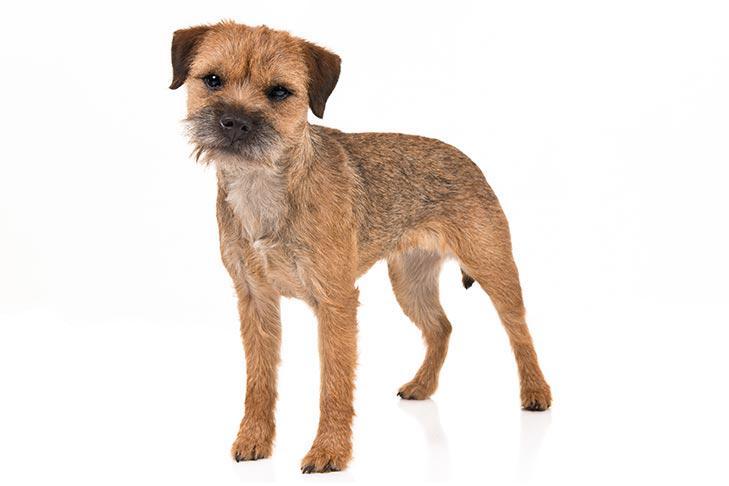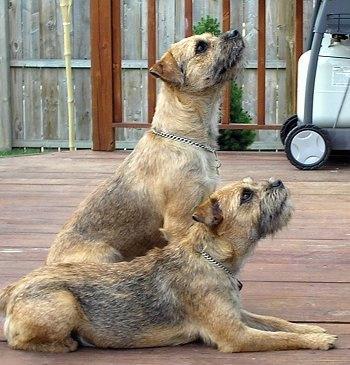The first image is the image on the left, the second image is the image on the right. For the images displayed, is the sentence "There is a dog in the right image, sitting down." factually correct? Answer yes or no. Yes. The first image is the image on the left, the second image is the image on the right. For the images displayed, is the sentence "Each image contains only one dog and one is sitting in one image and standing in the other image." factually correct? Answer yes or no. No. 